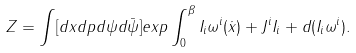Convert formula to latex. <formula><loc_0><loc_0><loc_500><loc_500>Z = \int [ d x d p d \psi d \bar { \psi } ] e x p \int _ { 0 } ^ { \beta } I _ { i } \omega ^ { i } ( \dot { x } ) + J ^ { i } I _ { i } + d ( I _ { i } \omega ^ { i } ) .</formula> 